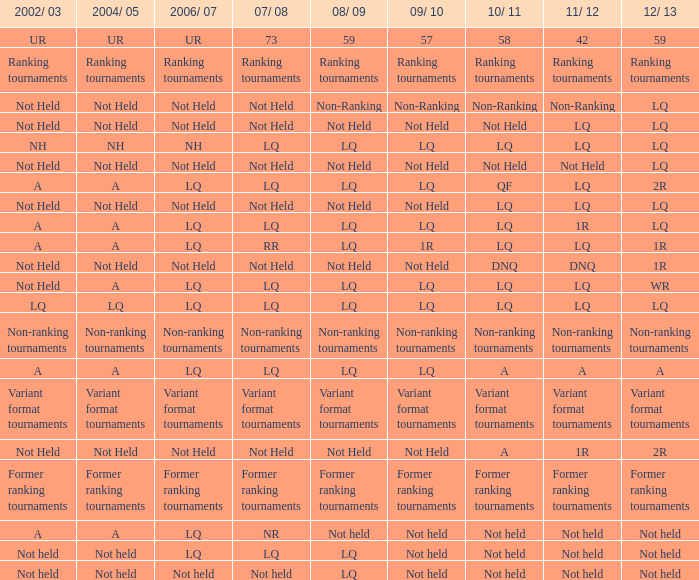Name the 2011/12 with 2008/09 of not held with 2010/11 of not held LQ, Not Held, Not held. 